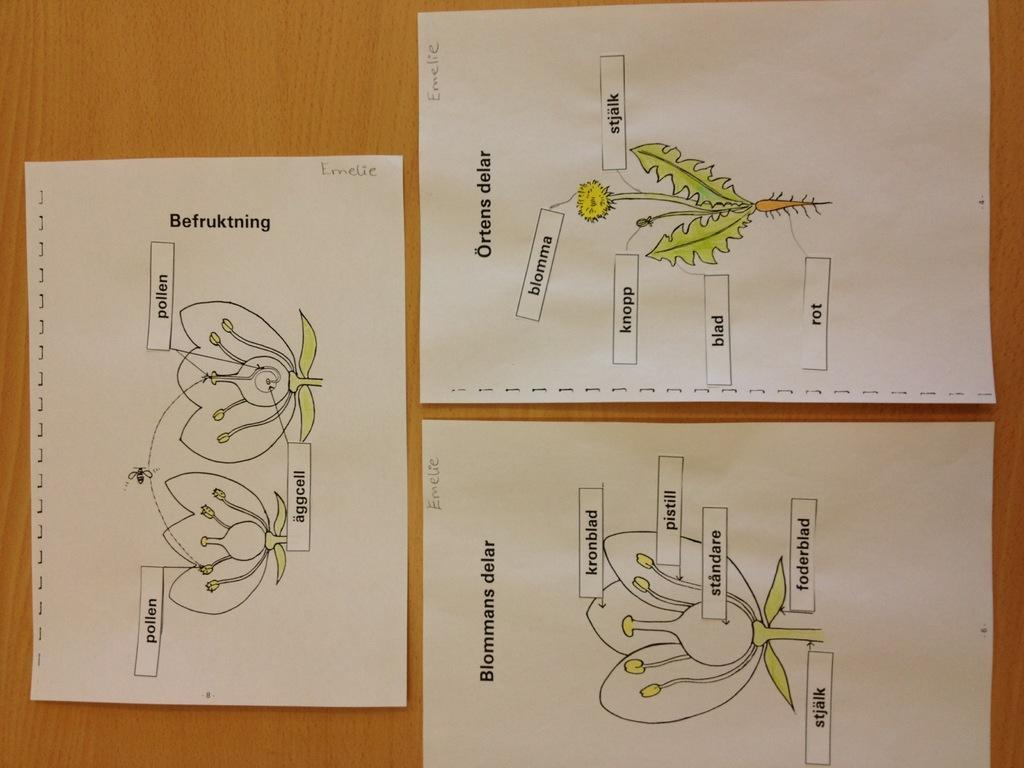How many papers are visible in the image? There are three papers in the image. What is the papers attached to? The papers are attached to a wooden surface. What can be seen on the papers? The papers contain images of plants in green color. What type of soda is being poured into the window in the image? There is no soda or window present in the image. 